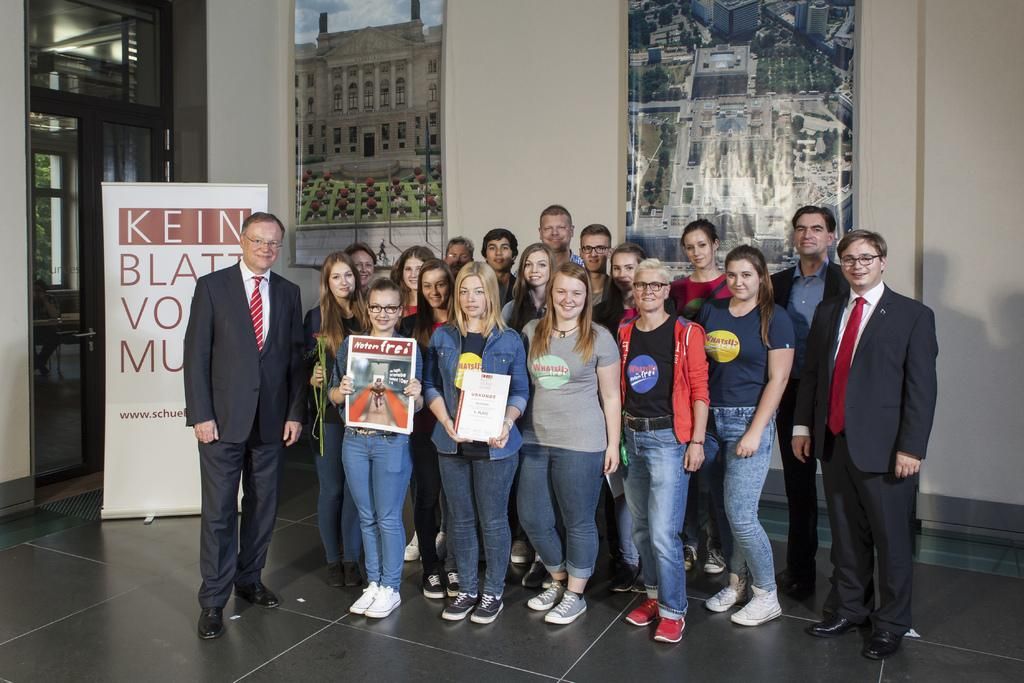What are the people in the foreground of the image doing? The people in the foreground of the image are standing and holding posters. What might be the purpose of the posters? The people are posing for a camera, so the posters might be related to a protest, event, or cause. What can be seen in the background of the image? There are posters, a banner, and a door visible in the background. What is the purpose of the banner in the background? The banner's purpose cannot be determined from the image alone, but it might be related to the same cause or event as the posters. What type of scarf is draped over the door in the background? There is no scarf visible on the door in the image. What kind of curve can be seen in the banner in the background? The banner in the background is not visible in enough detail to determine if there are any curves present. 